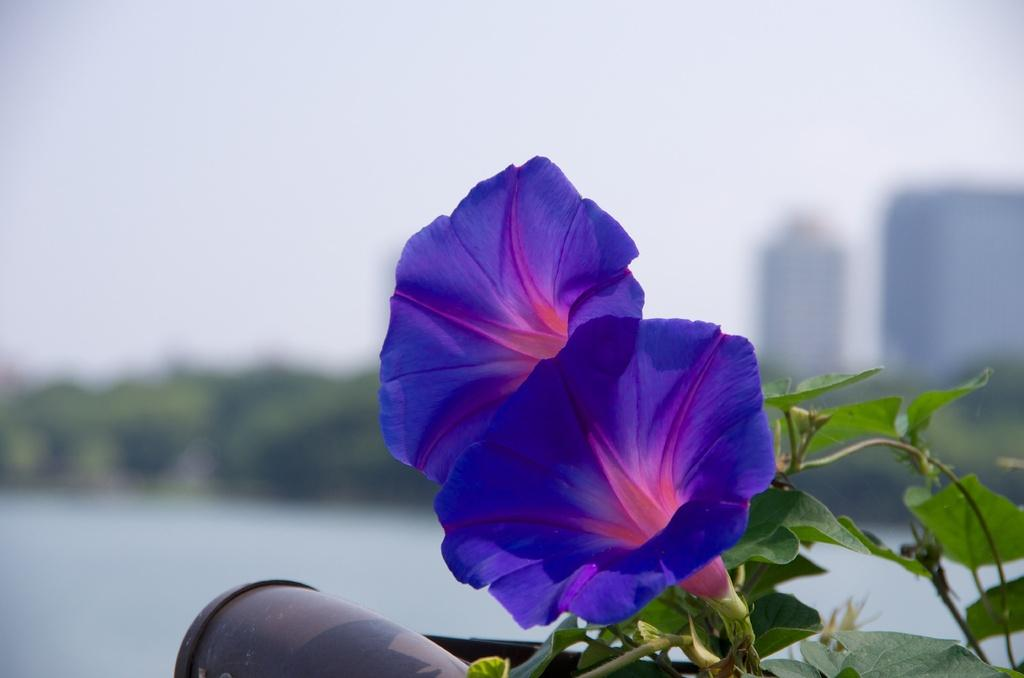What type of plant is visible in the image? There are flowers on a plant in the image. What is located near the flowers? There is an object near the flowers. How would you describe the background of the image? The background of the image is blurry. What type of chess piece is visible on the plant in the image? There is no chess piece present in the image; it features a plant with flowers and an unspecified object nearby. 